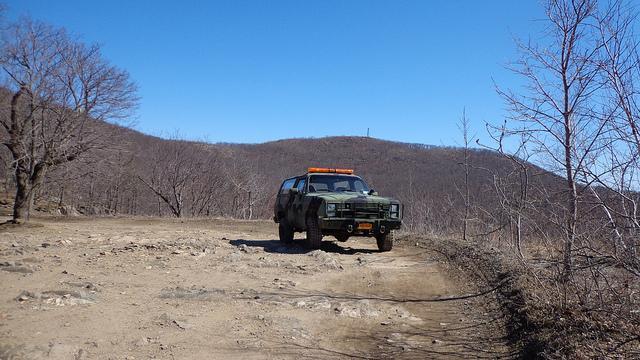How many bicycles are on the blue sign?
Give a very brief answer. 0. 